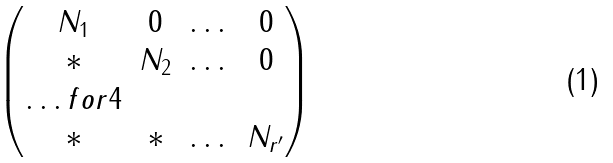<formula> <loc_0><loc_0><loc_500><loc_500>\begin{pmatrix} N _ { 1 } & 0 & \dots & 0 \\ * & N _ { 2 } & \dots & 0 \\ \hdots f o r { 4 } \\ * & * & \dots & N _ { r ^ { \prime } } \end{pmatrix}</formula> 